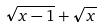Convert formula to latex. <formula><loc_0><loc_0><loc_500><loc_500>\sqrt { x - 1 } + \sqrt { x }</formula> 